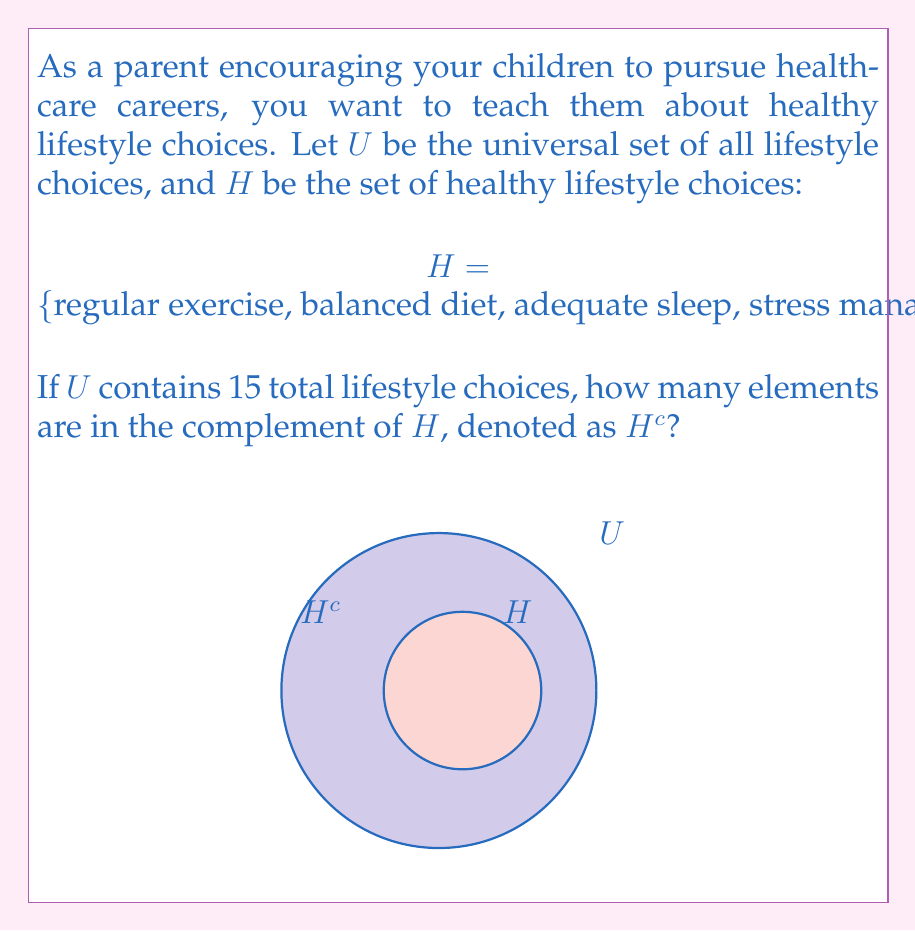Provide a solution to this math problem. Let's approach this step-by-step:

1) First, recall that the complement of a set $A$, denoted $A^c$, is the set of all elements in the universal set $U$ that are not in $A$.

2) We're given that $U$ contains 15 total lifestyle choices.

3) We're also given the set $H$, which contains 5 healthy lifestyle choices:
   $|H| = 5$

4) To find the number of elements in $H^c$, we can use the formula:
   $|H^c| = |U| - |H|$

5) Substituting the values:
   $|H^c| = 15 - 5 = 10$

Therefore, there are 10 elements in the complement of $H$. These would represent lifestyle choices that are not considered healthy, such as sedentary behavior, poor diet, insufficient sleep, etc.

As a parent encouraging healthcare careers, you could use this to discuss with your children the importance of promoting healthy choices and educating others about avoiding unhealthy habits in their future roles as healthcare professionals.
Answer: $|H^c| = 10$ 